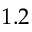<formula> <loc_0><loc_0><loc_500><loc_500>1 . 2</formula> 